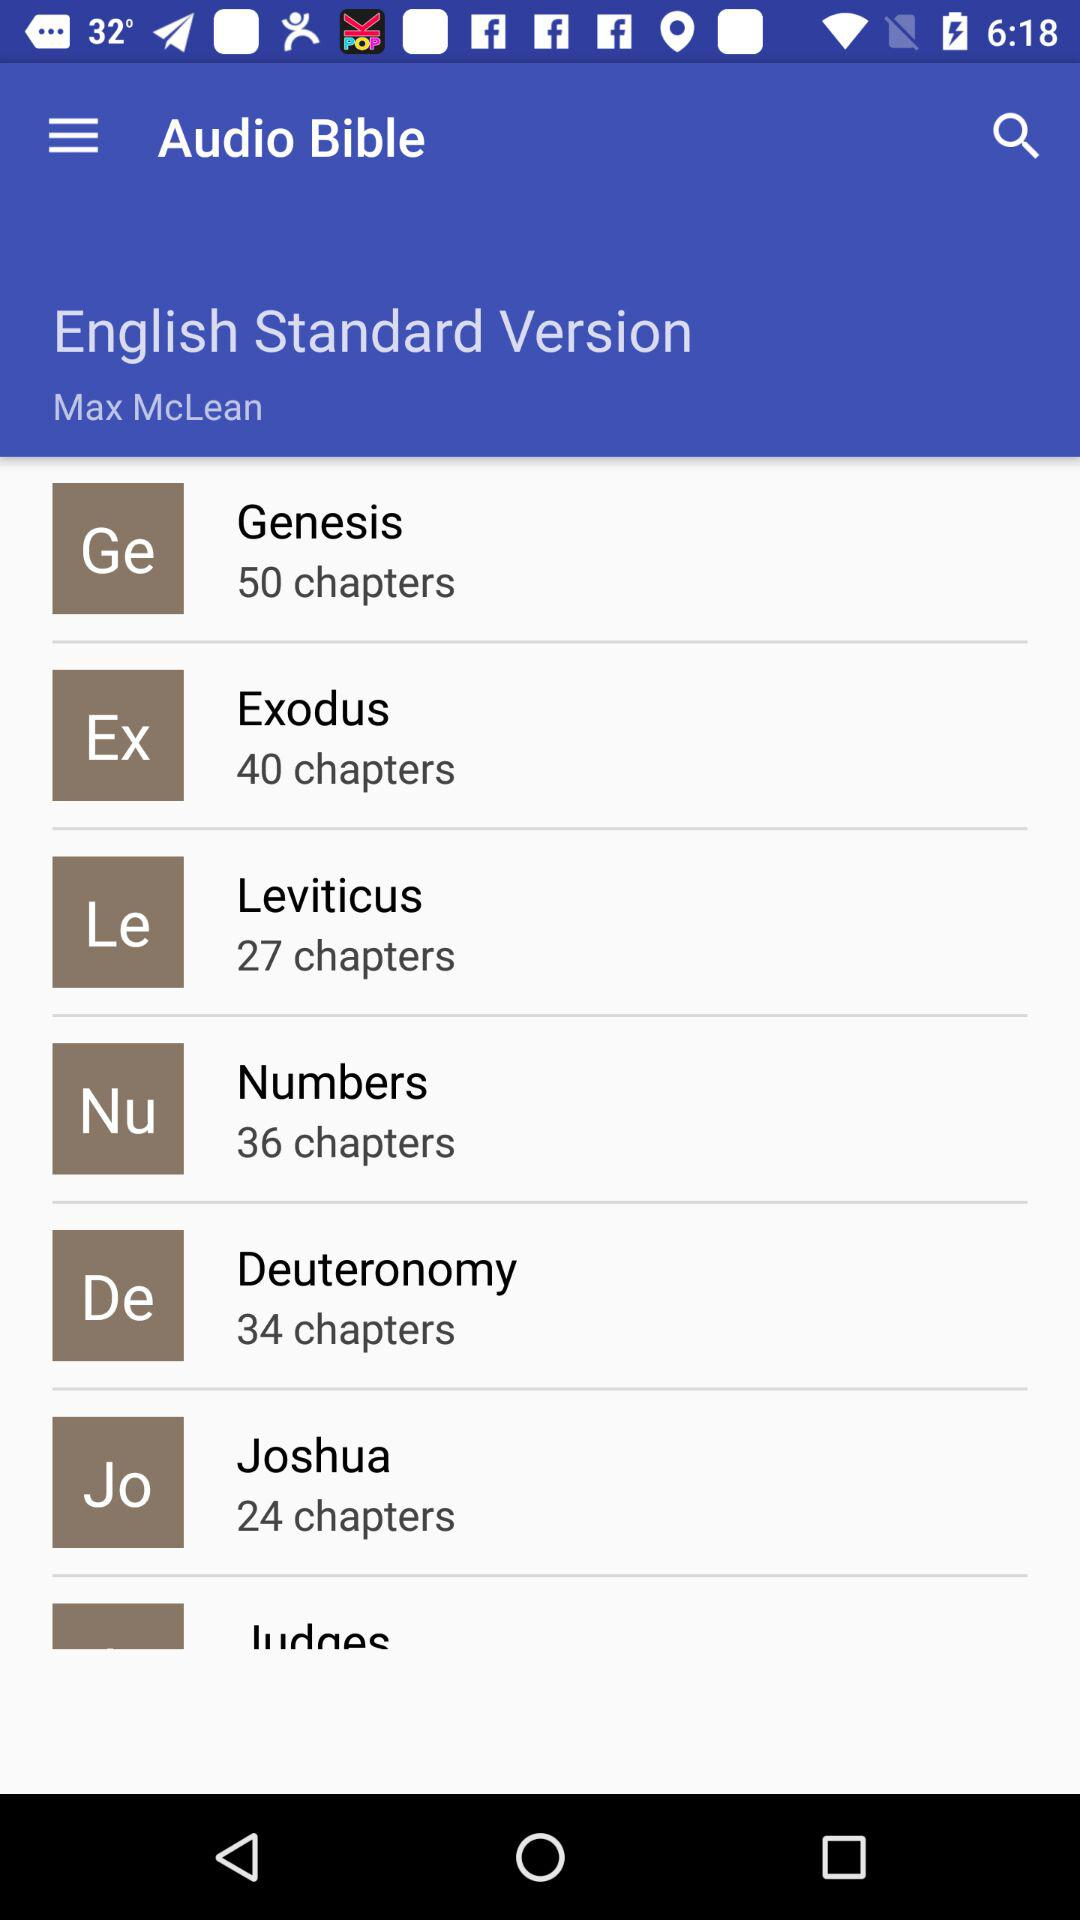How many chapters are there in "Numbers"? There are 36 chapters in "Numbers". 